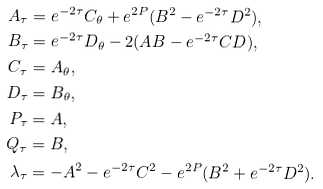<formula> <loc_0><loc_0><loc_500><loc_500>A _ { \tau } & = e ^ { - 2 \tau } C _ { \theta } + e ^ { 2 P } ( B ^ { 2 } - e ^ { - 2 \tau } D ^ { 2 } ) , \\ B _ { \tau } & = e ^ { - 2 \tau } D _ { \theta } - 2 ( A B - e ^ { - 2 \tau } C D ) , \\ C _ { \tau } & = A _ { \theta } , \\ D _ { \tau } & = B _ { \theta } , \\ P _ { \tau } & = A , \\ Q _ { \tau } & = B , \\ \lambda _ { \tau } & = - A ^ { 2 } - e ^ { - 2 \tau } C ^ { 2 } - e ^ { 2 P } ( B ^ { 2 } + e ^ { - 2 \tau } D ^ { 2 } ) .</formula> 